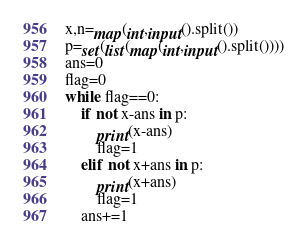Convert code to text. <code><loc_0><loc_0><loc_500><loc_500><_Python_>x,n=map(int,input().split())
p=set(list(map(int,input().split())))
ans=0
flag=0
while flag==0:
    if not x-ans in p:
        print(x-ans)
        flag=1
    elif not x+ans in p:
        print(x+ans)
        flag=1
    ans+=1
</code> 